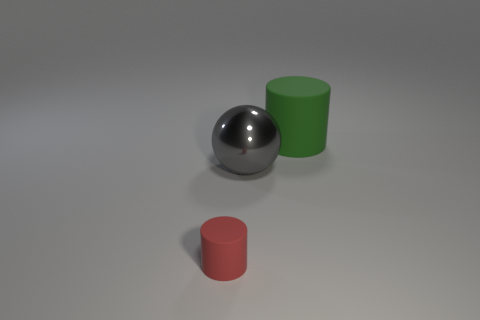There is another object that is the same shape as the green rubber thing; what size is it?
Provide a succinct answer. Small. How many objects are either cylinders in front of the green rubber object or big brown rubber objects?
Your response must be concise. 1. There is a matte thing on the left side of the rubber thing on the right side of the red matte cylinder; what is its shape?
Keep it short and to the point. Cylinder. Is there a green matte thing that has the same size as the gray sphere?
Offer a very short reply. Yes. Is the number of tiny objects greater than the number of blue balls?
Provide a short and direct response. Yes. Do the gray thing right of the red matte cylinder and the rubber cylinder behind the tiny cylinder have the same size?
Provide a short and direct response. Yes. What number of objects are left of the big green rubber cylinder and behind the red thing?
Offer a very short reply. 1. There is another matte thing that is the same shape as the tiny red rubber thing; what color is it?
Your answer should be very brief. Green. Are there fewer red cylinders than big blue metal cylinders?
Keep it short and to the point. No. There is a green cylinder; does it have the same size as the matte cylinder that is left of the gray sphere?
Your response must be concise. No. 